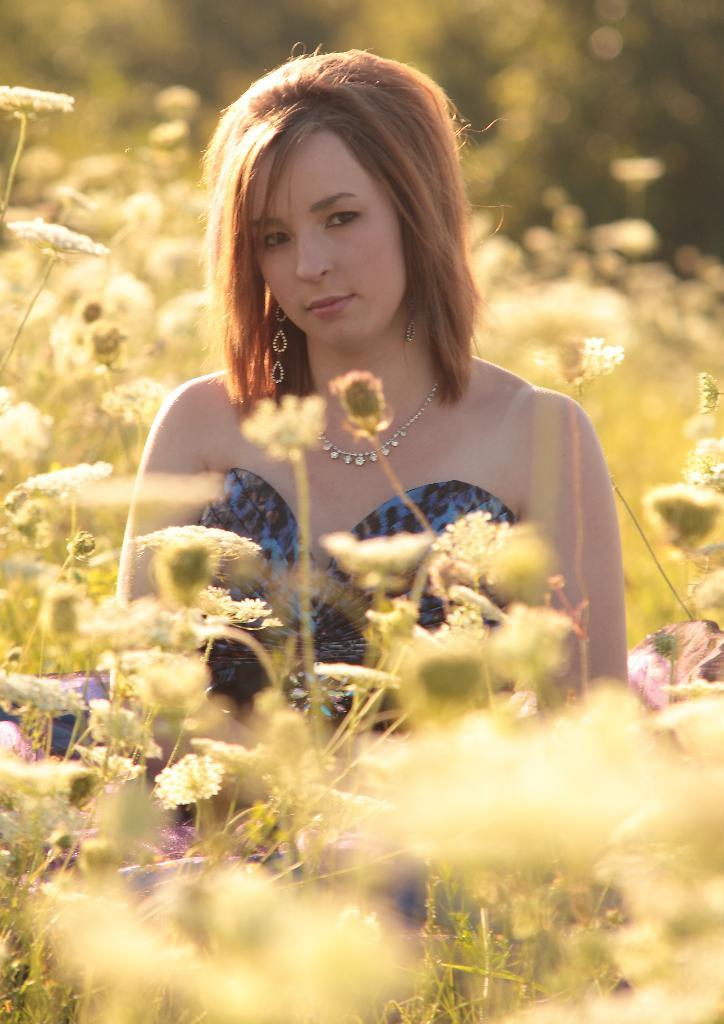Who is present in the image? There is a woman in the image. What is the woman wearing? The woman is wearing a dress. What else can be seen in the image besides the woman? There are plants in the image. What type of cherry is the woman holding in the image? There is no cherry present in the image; the woman is not holding anything. Is there a glove visible on the woman's hand in the image? There is no glove visible on the woman's hand in the image. 